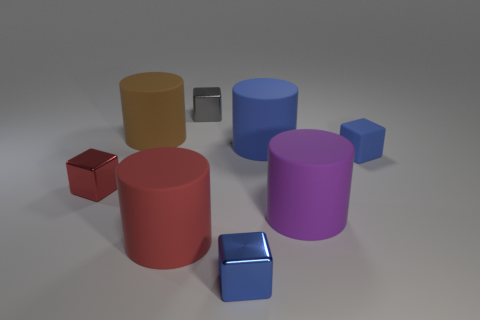How many large gray blocks are there?
Provide a succinct answer. 0. What number of big objects are either rubber cylinders or red blocks?
Provide a short and direct response. 4. There is a small block that is behind the blue cube behind the tiny metal block on the left side of the big brown object; what is its color?
Make the answer very short. Gray. How many other objects are the same color as the tiny rubber thing?
Make the answer very short. 2. How many matte things are brown cylinders or blue blocks?
Provide a succinct answer. 2. There is a thing on the left side of the brown matte cylinder; is it the same color as the big object that is in front of the purple matte thing?
Make the answer very short. Yes. What size is the blue shiny thing that is the same shape as the tiny gray thing?
Your answer should be compact. Small. Is the number of big matte cylinders that are in front of the large brown rubber object greater than the number of big purple rubber objects?
Your response must be concise. Yes. Are the big brown object that is left of the purple matte cylinder and the purple cylinder made of the same material?
Offer a very short reply. Yes. How big is the blue block that is left of the tiny blue block right of the small object in front of the large purple rubber cylinder?
Offer a terse response. Small. 